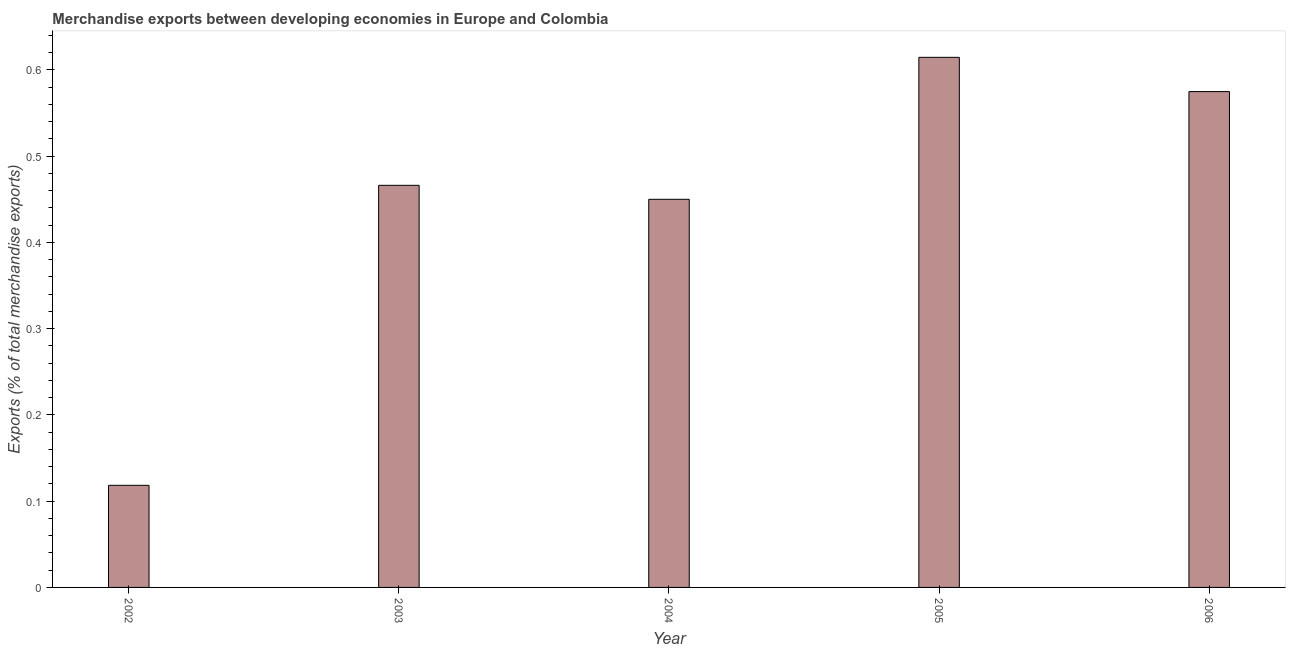Does the graph contain grids?
Your answer should be compact. No. What is the title of the graph?
Offer a very short reply. Merchandise exports between developing economies in Europe and Colombia. What is the label or title of the Y-axis?
Offer a terse response. Exports (% of total merchandise exports). What is the merchandise exports in 2005?
Give a very brief answer. 0.61. Across all years, what is the maximum merchandise exports?
Provide a short and direct response. 0.61. Across all years, what is the minimum merchandise exports?
Your answer should be very brief. 0.12. In which year was the merchandise exports maximum?
Offer a very short reply. 2005. In which year was the merchandise exports minimum?
Provide a succinct answer. 2002. What is the sum of the merchandise exports?
Provide a succinct answer. 2.22. What is the difference between the merchandise exports in 2004 and 2005?
Provide a short and direct response. -0.17. What is the average merchandise exports per year?
Make the answer very short. 0.45. What is the median merchandise exports?
Provide a short and direct response. 0.47. In how many years, is the merchandise exports greater than 0.52 %?
Provide a succinct answer. 2. What is the ratio of the merchandise exports in 2003 to that in 2005?
Keep it short and to the point. 0.76. Is the merchandise exports in 2002 less than that in 2004?
Make the answer very short. Yes. Is the sum of the merchandise exports in 2005 and 2006 greater than the maximum merchandise exports across all years?
Provide a succinct answer. Yes. Are all the bars in the graph horizontal?
Offer a terse response. No. How many years are there in the graph?
Offer a terse response. 5. What is the difference between two consecutive major ticks on the Y-axis?
Your answer should be compact. 0.1. What is the Exports (% of total merchandise exports) of 2002?
Keep it short and to the point. 0.12. What is the Exports (% of total merchandise exports) of 2003?
Provide a succinct answer. 0.47. What is the Exports (% of total merchandise exports) of 2004?
Your answer should be very brief. 0.45. What is the Exports (% of total merchandise exports) in 2005?
Your answer should be very brief. 0.61. What is the Exports (% of total merchandise exports) in 2006?
Provide a short and direct response. 0.57. What is the difference between the Exports (% of total merchandise exports) in 2002 and 2003?
Make the answer very short. -0.35. What is the difference between the Exports (% of total merchandise exports) in 2002 and 2004?
Your answer should be compact. -0.33. What is the difference between the Exports (% of total merchandise exports) in 2002 and 2005?
Provide a succinct answer. -0.5. What is the difference between the Exports (% of total merchandise exports) in 2002 and 2006?
Provide a short and direct response. -0.46. What is the difference between the Exports (% of total merchandise exports) in 2003 and 2004?
Keep it short and to the point. 0.02. What is the difference between the Exports (% of total merchandise exports) in 2003 and 2005?
Your response must be concise. -0.15. What is the difference between the Exports (% of total merchandise exports) in 2003 and 2006?
Your answer should be compact. -0.11. What is the difference between the Exports (% of total merchandise exports) in 2004 and 2005?
Give a very brief answer. -0.16. What is the difference between the Exports (% of total merchandise exports) in 2004 and 2006?
Ensure brevity in your answer.  -0.12. What is the difference between the Exports (% of total merchandise exports) in 2005 and 2006?
Offer a terse response. 0.04. What is the ratio of the Exports (% of total merchandise exports) in 2002 to that in 2003?
Offer a terse response. 0.25. What is the ratio of the Exports (% of total merchandise exports) in 2002 to that in 2004?
Offer a terse response. 0.26. What is the ratio of the Exports (% of total merchandise exports) in 2002 to that in 2005?
Offer a very short reply. 0.19. What is the ratio of the Exports (% of total merchandise exports) in 2002 to that in 2006?
Ensure brevity in your answer.  0.21. What is the ratio of the Exports (% of total merchandise exports) in 2003 to that in 2004?
Keep it short and to the point. 1.04. What is the ratio of the Exports (% of total merchandise exports) in 2003 to that in 2005?
Keep it short and to the point. 0.76. What is the ratio of the Exports (% of total merchandise exports) in 2003 to that in 2006?
Ensure brevity in your answer.  0.81. What is the ratio of the Exports (% of total merchandise exports) in 2004 to that in 2005?
Make the answer very short. 0.73. What is the ratio of the Exports (% of total merchandise exports) in 2004 to that in 2006?
Make the answer very short. 0.78. What is the ratio of the Exports (% of total merchandise exports) in 2005 to that in 2006?
Ensure brevity in your answer.  1.07. 